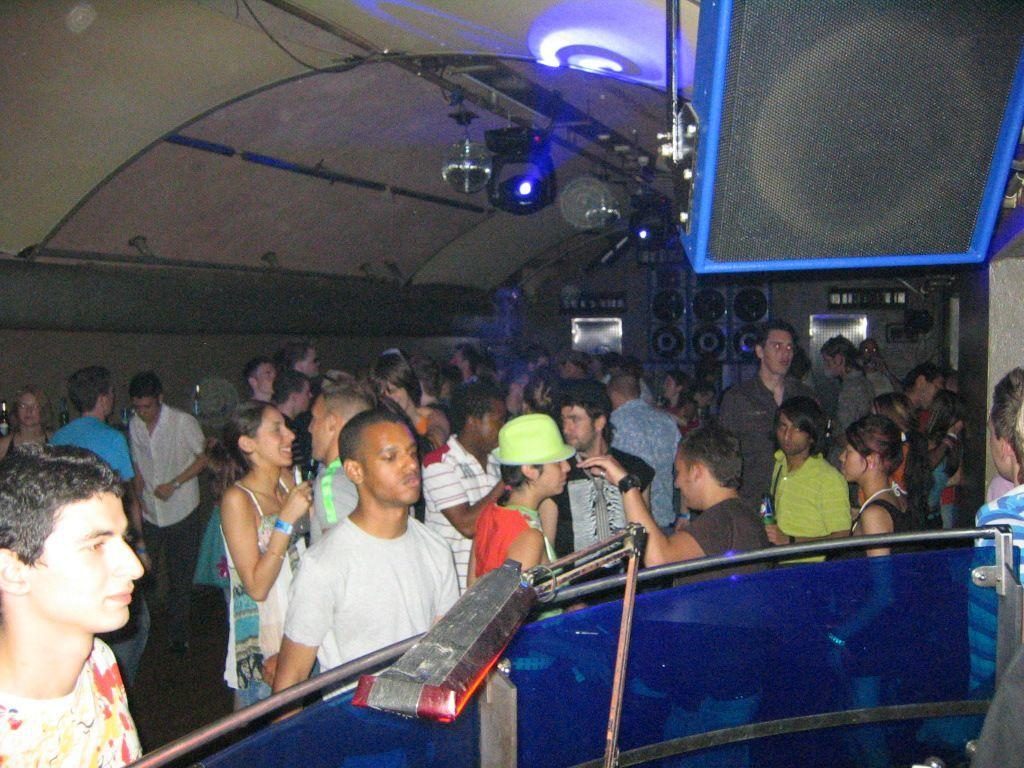What can be seen in the image? There are people standing in the image. What is visible in the background of the image? There are walls and speakers in the background of the image. What is visible at the top of the image? There is a roof and lights visible at the top of the image. What is present at the bottom of the image? There is a railing at the bottom of the image. Can you tell me how many crows are sitting on the railing in the image? There are no crows present in the image; the railing is the only element visible at the bottom of the image. 